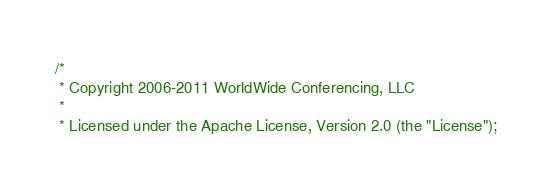Convert code to text. <code><loc_0><loc_0><loc_500><loc_500><_Scala_>/*
 * Copyright 2006-2011 WorldWide Conferencing, LLC
 *
 * Licensed under the Apache License, Version 2.0 (the "License");</code> 